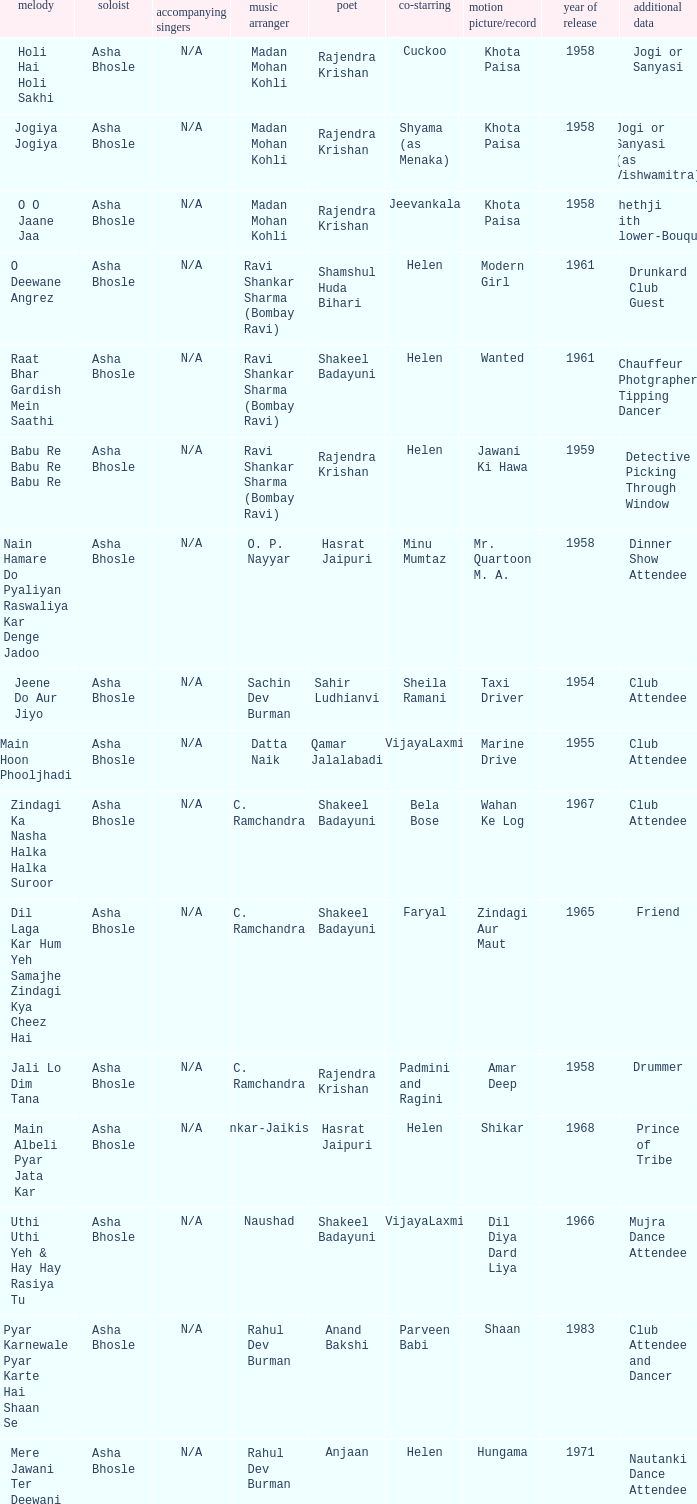Who wrote the lyrics when Jeevankala co-starred? Rajendra Krishan. 